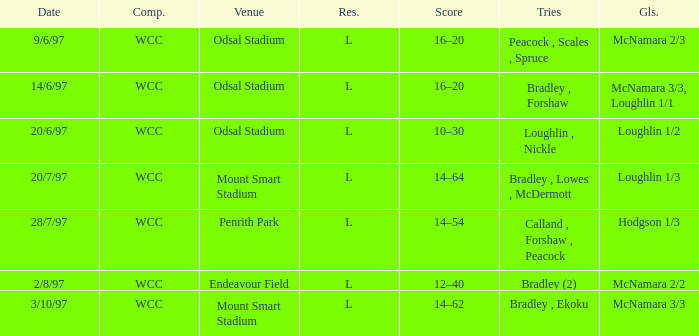Could you parse the entire table as a dict? {'header': ['Date', 'Comp.', 'Venue', 'Res.', 'Score', 'Tries', 'Gls.'], 'rows': [['9/6/97', 'WCC', 'Odsal Stadium', 'L', '16–20', 'Peacock , Scales , Spruce', 'McNamara 2/3'], ['14/6/97', 'WCC', 'Odsal Stadium', 'L', '16–20', 'Bradley , Forshaw', 'McNamara 3/3, Loughlin 1/1'], ['20/6/97', 'WCC', 'Odsal Stadium', 'L', '10–30', 'Loughlin , Nickle', 'Loughlin 1/2'], ['20/7/97', 'WCC', 'Mount Smart Stadium', 'L', '14–64', 'Bradley , Lowes , McDermott', 'Loughlin 1/3'], ['28/7/97', 'WCC', 'Penrith Park', 'L', '14–54', 'Calland , Forshaw , Peacock', 'Hodgson 1/3'], ['2/8/97', 'WCC', 'Endeavour Field', 'L', '12–40', 'Bradley (2)', 'McNamara 2/2'], ['3/10/97', 'WCC', 'Mount Smart Stadium', 'L', '14–62', 'Bradley , Ekoku', 'McNamara 3/3']]} What were the tries on 14/6/97? Bradley , Forshaw. 